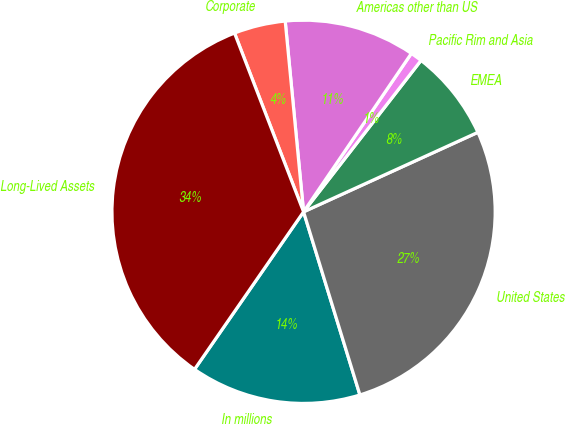<chart> <loc_0><loc_0><loc_500><loc_500><pie_chart><fcel>In millions<fcel>United States<fcel>EMEA<fcel>Pacific Rim and Asia<fcel>Americas other than US<fcel>Corporate<fcel>Long-Lived Assets<nl><fcel>14.39%<fcel>27.06%<fcel>7.69%<fcel>0.99%<fcel>11.04%<fcel>4.34%<fcel>34.5%<nl></chart> 